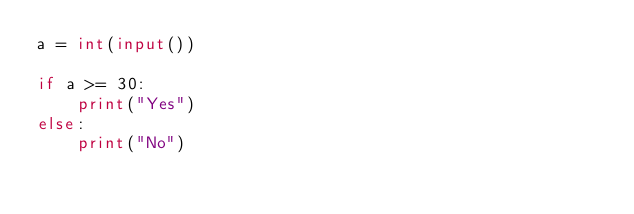<code> <loc_0><loc_0><loc_500><loc_500><_Python_>a = int(input())

if a >= 30:
    print("Yes")
else:
    print("No")</code> 